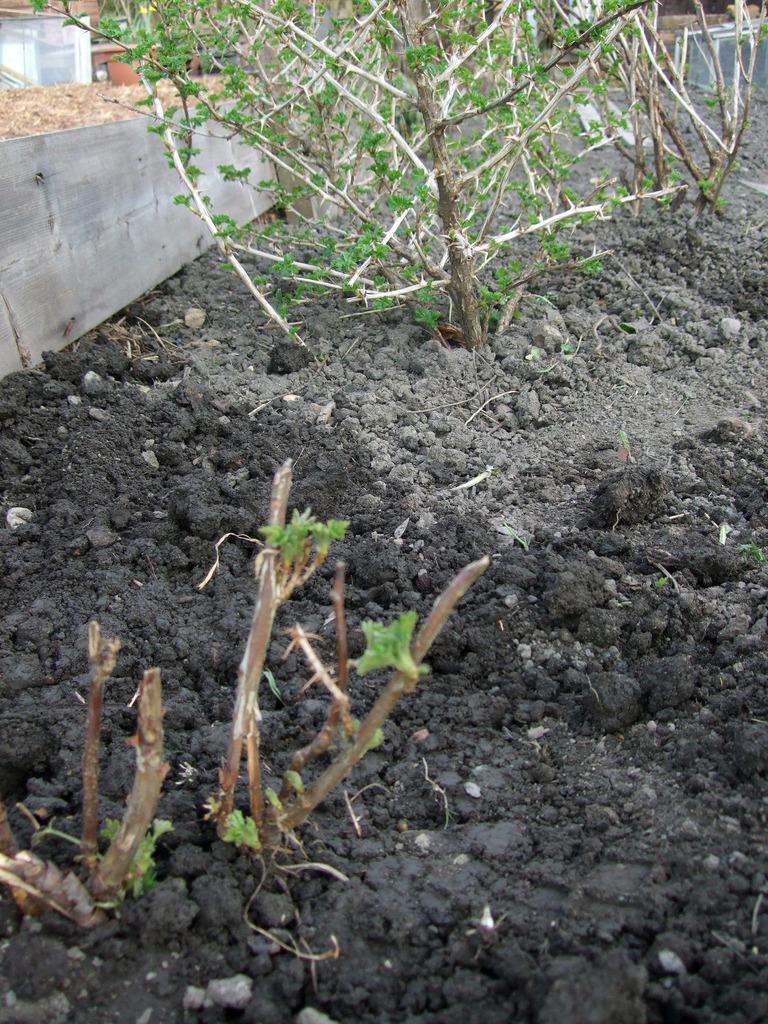In one or two sentences, can you explain what this image depicts? In this image we can see some plants on the ground and on the left side there is an object which looks like a wooden plank. 